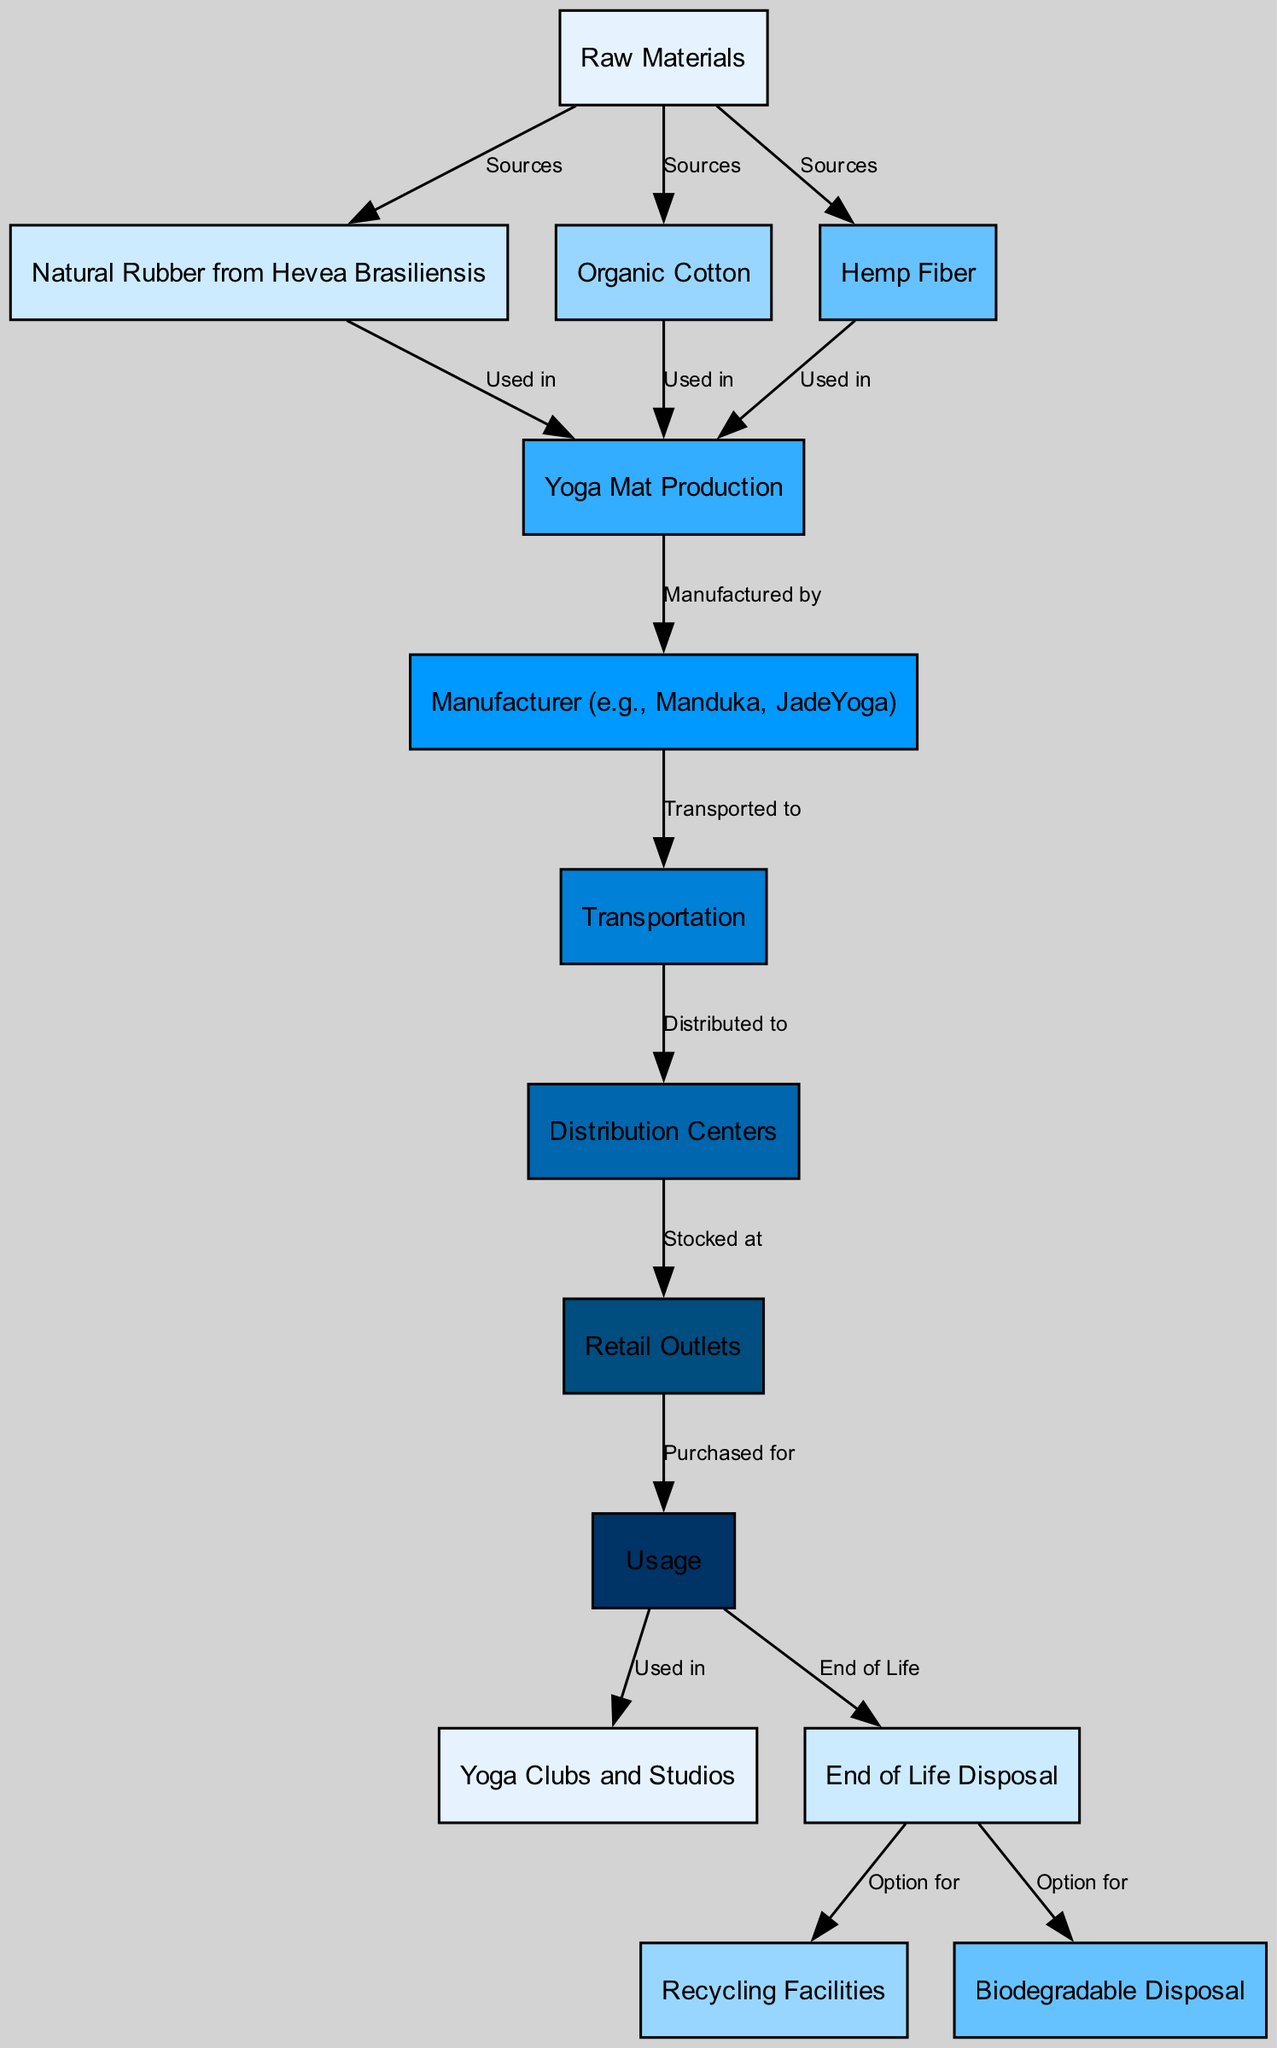What are the raw materials sourced for yoga mats? Examining the diagram, the first step is to identify the "Raw Materials" node. From there, I look at the edges leading from it, which show three connections labeled "Sources." These connections lead to the nodes "Natural Rubber from Hevea Brasiliensis," "Organic Cotton," and "Hemp Fiber." Therefore, the raw materials sourced for yoga mats are these three elements.
Answer: Natural Rubber from Hevea Brasiliensis, Organic Cotton, Hemp Fiber Who manufactures the yoga mats? In the diagram, after tracing from the "Production" node to its succeeding node, there’s a direct connection labeled "Manufactured by" leading to the "Manufacturer (e.g., Manduka, JadeYoga)" node. This indicates that the manufacturers not only represent one specific brand but a category of brands that produce yoga mats.
Answer: Manufacturer (e.g., Manduka, JadeYoga) What is the next step after yoga mat production? Following the production process, we observe the edge labeled "Manufactured by," leading us to the next node, which is the "Transportation" node. This indicates the transition from production to how the finished mats are transported.
Answer: Transportation What happens to a yoga mat at the end of its life? Upon reaching the "Use" node, I notice that it has an edge directing to the "Disposal" node, labeled "End of Life." Therefore, at the end of its life, a yoga mat is disposed of, leading to the next options available.
Answer: Disposal What options are available for yoga mat disposal? From the "Disposal" node, two connections emerge, indicating possible outcomes for the yoga mat at the end of its life. One edge leads to "Recycling Facilities" and another to "Biodegradable Disposal." This implies that the control options available call for either recycling or biodegradable disposal.
Answer: Recycling Facilities, Biodegradable Disposal How many nodes are involved in the food chain of yoga mats? To determine the number of nodes, I count each distinct node shown in the diagram. There are a total of 13 nodes listed, and upon verification, I confirm this count by matching them with what is detailed in the provided information.
Answer: 13 What is the relationship between "Retail Outlets" and "Usage"? Analyzing the relevant edges, there’s a direct connection from "Retail Outlets" to the "Usage" node with the label "Purchased for." This relationship identifies the process in which yoga mats are bought at retail outlets to be used subsequently.
Answer: Purchased for What precedes transportation in the food chain? Looking at the flow of the diagram, there’s a direct connection where the "Manufacturer" node leads to "Transportation." This indicates that manufacturing occurs before transportation takes place in the food chain.
Answer: Manufacturer 